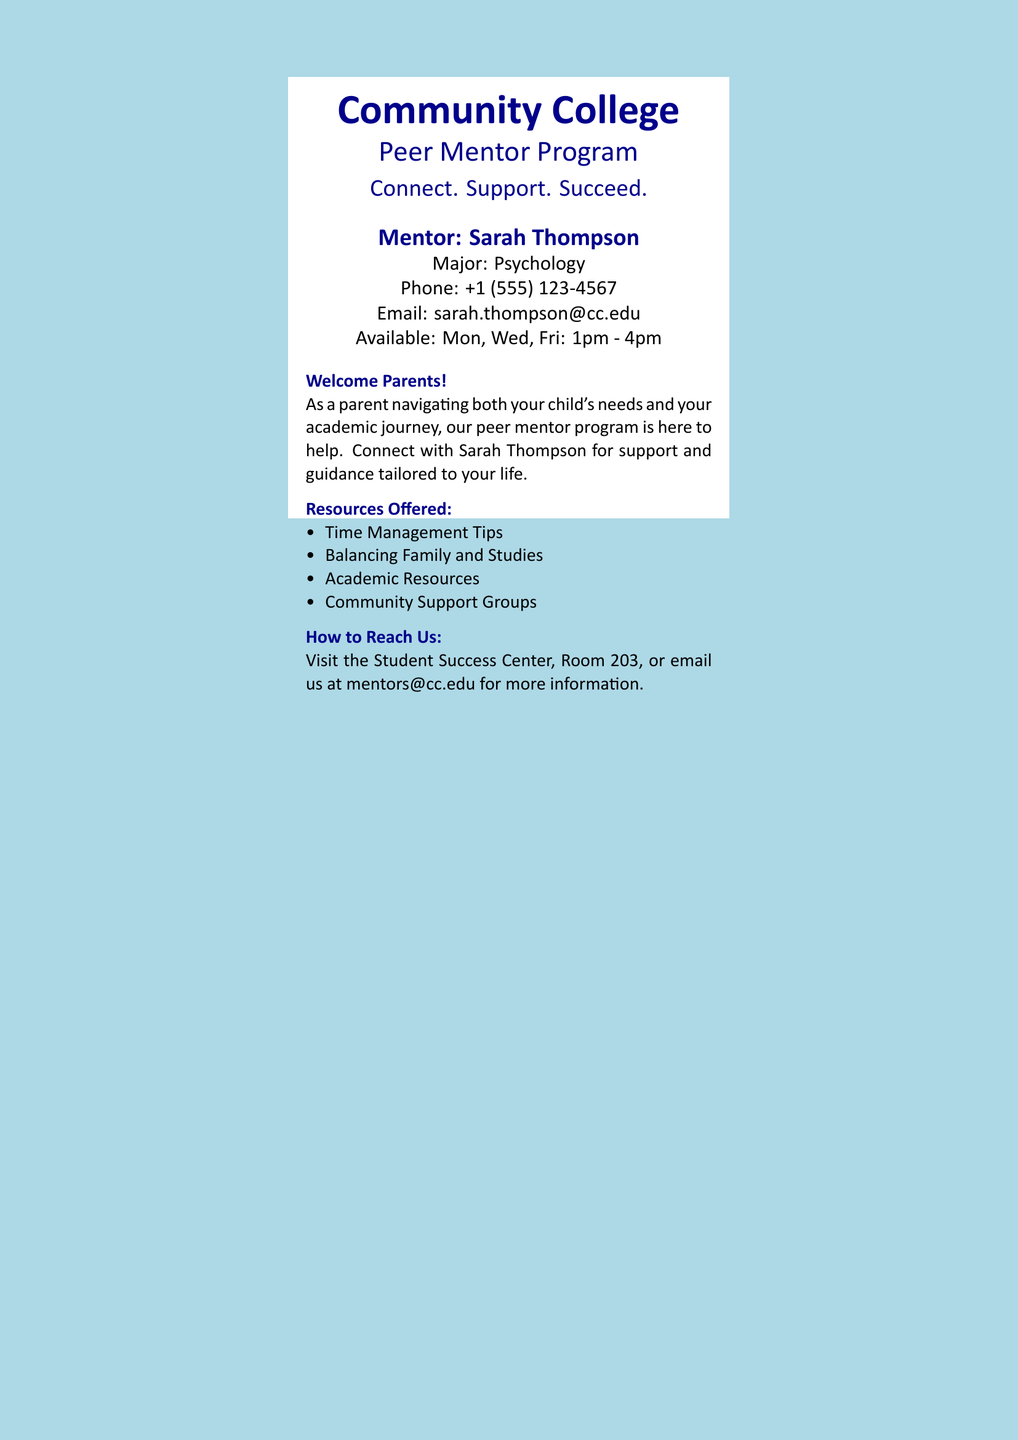What is the mentor's name? The mentor's name is explicitly stated in the document.
Answer: Sarah Thompson What is the mentor's major? The document lists the mentor's major under their name.
Answer: Psychology What is the phone number provided? The document includes the mentor's phone number for contact.
Answer: +1 (555) 123-4567 What days is the mentor available? The availability of the mentor is noted in the document.
Answer: Mon, Wed, Fri What are the available hours? The document specifies the hours the mentor is available for guidance.
Answer: 1pm - 4pm What kind of support does the Peer Mentor Program offer? The document lists specific resources offered to new students and parents.
Answer: Time Management Tips How can I reach the Peer Mentor Program? The document provides contact information for further inquiries.
Answer: Email us at mentors@cc.edu What is the purpose of the Peer Mentor Program? The mission statement of the program is included in the document.
Answer: Connect. Support. Succeed Where is the Student Success Center located? The document states a specific room location for the Student Success Center.
Answer: Room 203 